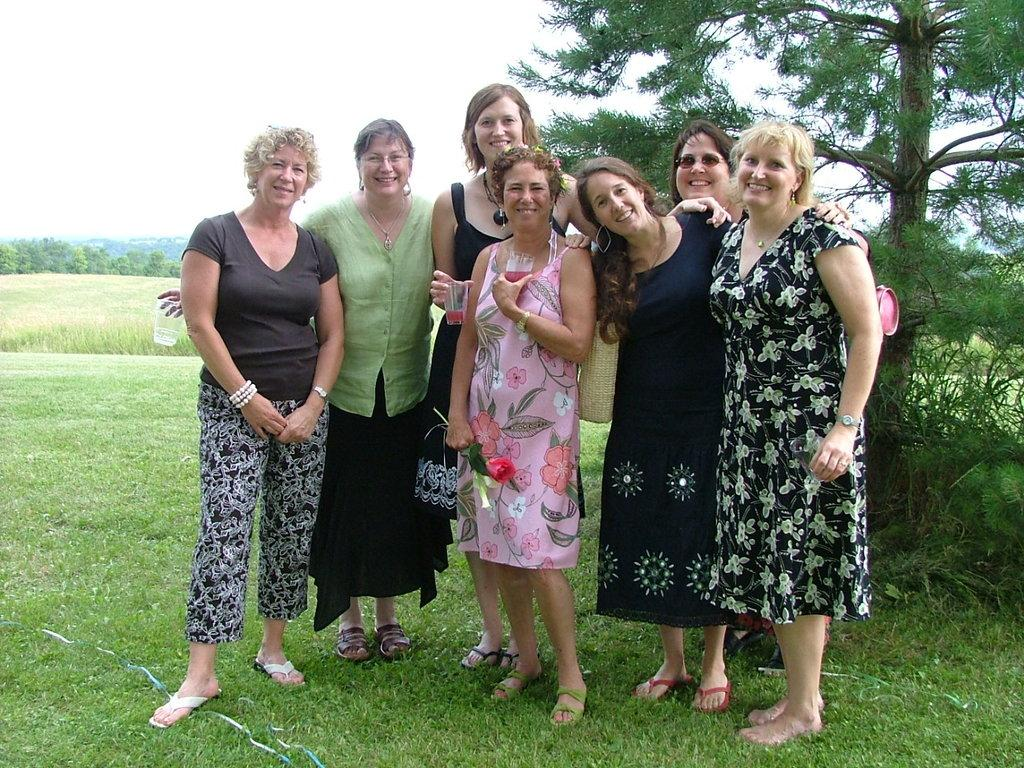What is the main subject in the foreground of the image? There is a woman standing on the grass in the foreground of the image. What is the woman doing in the image? The woman is posing to the camera. What can be seen behind the woman? There is a tree behind the woman. What is visible in the background of the image? Trees and the sky are visible in the background of the image. What type of animals can be seen attacking the woman in the image? There are no animals present in the image, let alone attacking the woman. 